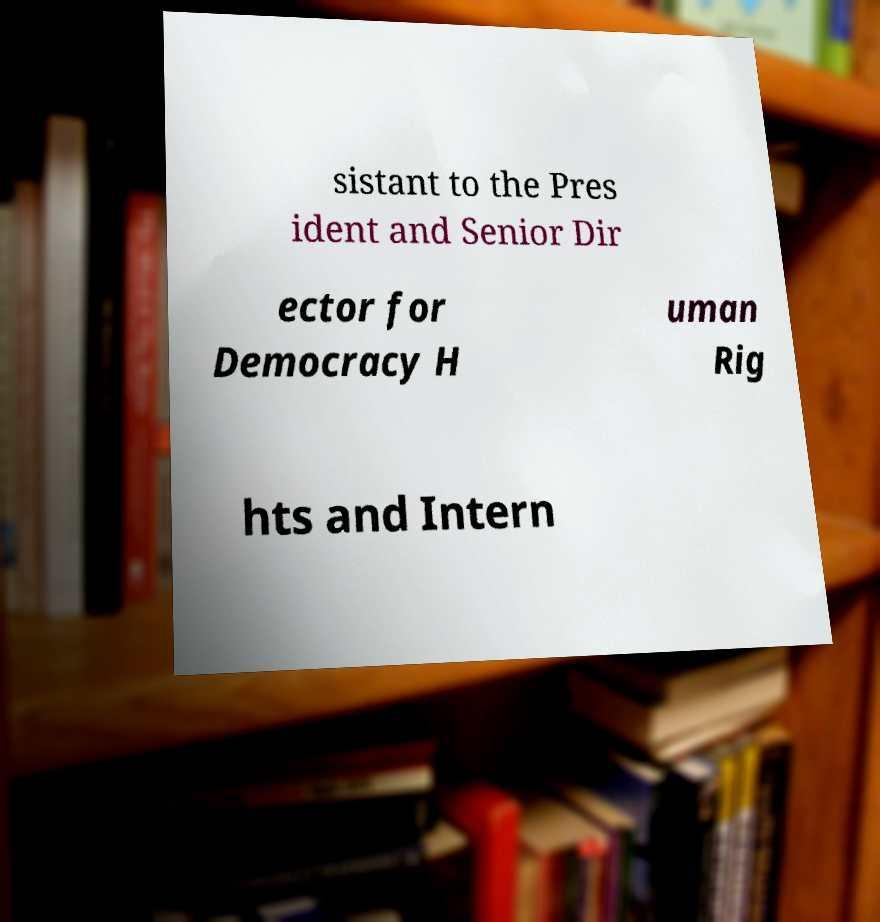There's text embedded in this image that I need extracted. Can you transcribe it verbatim? sistant to the Pres ident and Senior Dir ector for Democracy H uman Rig hts and Intern 